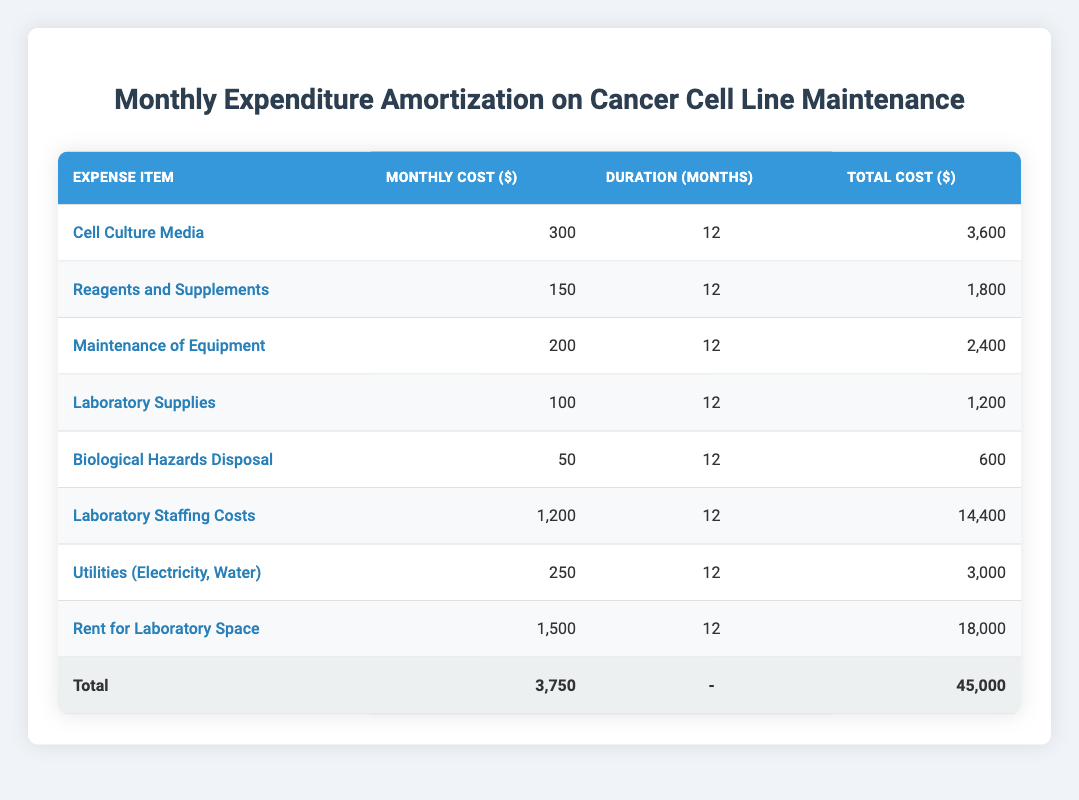What is the total cost for maintaining the laboratory space? To find the total cost for the laboratory space maintenance, refer to the 'Rent for Laboratory Space' row. The total cost is 18,000.
Answer: 18,000 What is the monthly expenditure for Biological Hazards Disposal? The monthly expenditure for Biological Hazards Disposal is found in the corresponding row, which lists a cost of 50.
Answer: 50 How much do the Laboratory Staffing Costs contribute to the total expenditure? Laboratory Staffing Costs is one of the expense items listed with a total cost of 14,400. To see its contribution, compare it with the total expenditure of 45,000. The contribution is substantial and calculated as (14,400/45,000) * 100 = 32%.
Answer: 32% What is the total monthly cost for all items combined? To find the total monthly cost, add up all the monthly costs: 300 + 150 + 200 + 100 + 50 + 1200 + 250 + 1500 = 3,750.
Answer: 3,750 Are the monthly costs for Utilities (Electricity, Water) less than the total cost for Cell Culture Media? Monthly costs for Utilities (250) need to be compared to the total cost of Cell Culture Media (3,600). Since 250 is less than 3,600, the statement is true.
Answer: Yes How many total months is each item planned for maintenance? Each item in the table is listed with a duration of 12 months. This consistent duration can be verified by checking each row where duration is mentioned.
Answer: 12 months Which expense has the lowest monthly cost? To determine this, compare the monthly costs listed: the lowest monthly cost is 50 for Biological Hazards Disposal, as it's less than all other items.
Answer: 50 What percentage of the total cost does Cell Culture Media represent? To find the percentage, divide the total cost for Cell Culture Media (3,600) by the total expenditure (45,000) and multiply by 100: (3,600/45,000) * 100 = 8%.
Answer: 8% What is the combined total cost for all laboratory supplies excluding Rent and Staffing? Add the total costs for Cell Culture Media, Reagents and Supplements, Maintenance of Equipment, Laboratory Supplies, Biological Hazards Disposal, and Utilities: 3,600 + 1,800 + 2,400 + 1,200 + 600 + 3,000 = 13,600.
Answer: 13,600 